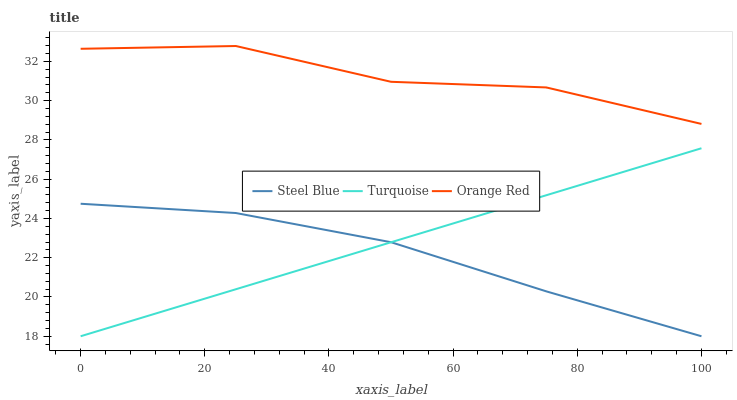Does Steel Blue have the minimum area under the curve?
Answer yes or no. Yes. Does Orange Red have the maximum area under the curve?
Answer yes or no. Yes. Does Orange Red have the minimum area under the curve?
Answer yes or no. No. Does Steel Blue have the maximum area under the curve?
Answer yes or no. No. Is Turquoise the smoothest?
Answer yes or no. Yes. Is Orange Red the roughest?
Answer yes or no. Yes. Is Steel Blue the smoothest?
Answer yes or no. No. Is Steel Blue the roughest?
Answer yes or no. No. Does Orange Red have the lowest value?
Answer yes or no. No. Does Orange Red have the highest value?
Answer yes or no. Yes. Does Steel Blue have the highest value?
Answer yes or no. No. Is Turquoise less than Orange Red?
Answer yes or no. Yes. Is Orange Red greater than Turquoise?
Answer yes or no. Yes. Does Turquoise intersect Steel Blue?
Answer yes or no. Yes. Is Turquoise less than Steel Blue?
Answer yes or no. No. Is Turquoise greater than Steel Blue?
Answer yes or no. No. Does Turquoise intersect Orange Red?
Answer yes or no. No. 